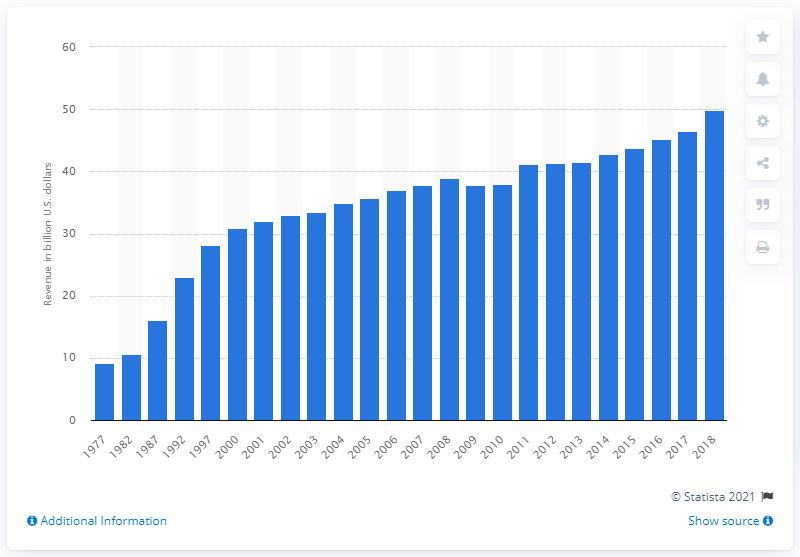Point out several critical features in this image. In 2018, state and local governments collected a total of $49.84 million through motor fuel tax. 